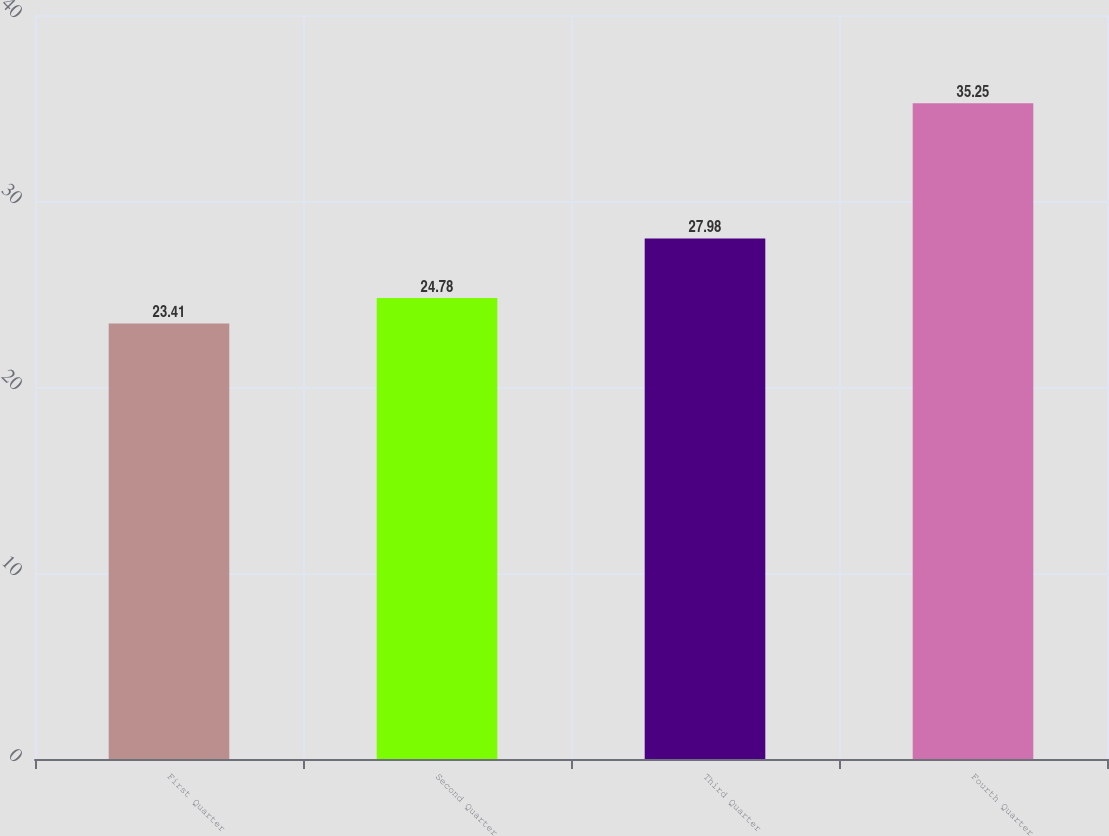<chart> <loc_0><loc_0><loc_500><loc_500><bar_chart><fcel>First Quarter<fcel>Second Quarter<fcel>Third Quarter<fcel>Fourth Quarter<nl><fcel>23.41<fcel>24.78<fcel>27.98<fcel>35.25<nl></chart> 